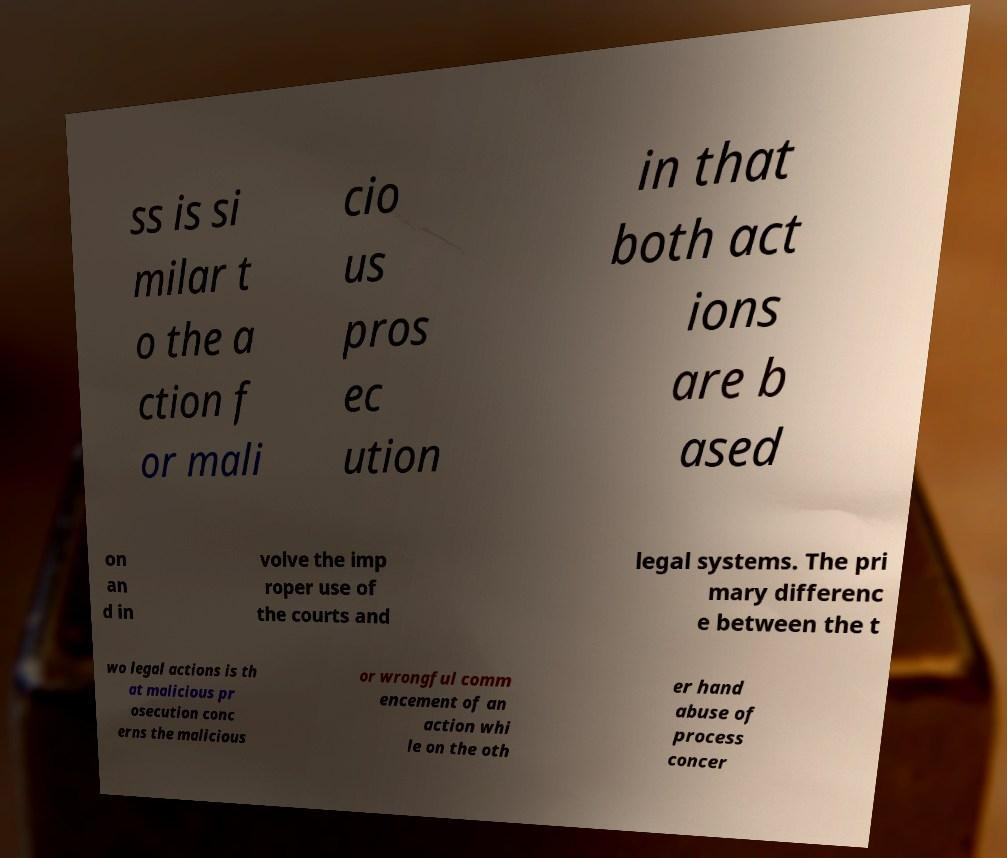Please identify and transcribe the text found in this image. ss is si milar t o the a ction f or mali cio us pros ec ution in that both act ions are b ased on an d in volve the imp roper use of the courts and legal systems. The pri mary differenc e between the t wo legal actions is th at malicious pr osecution conc erns the malicious or wrongful comm encement of an action whi le on the oth er hand abuse of process concer 